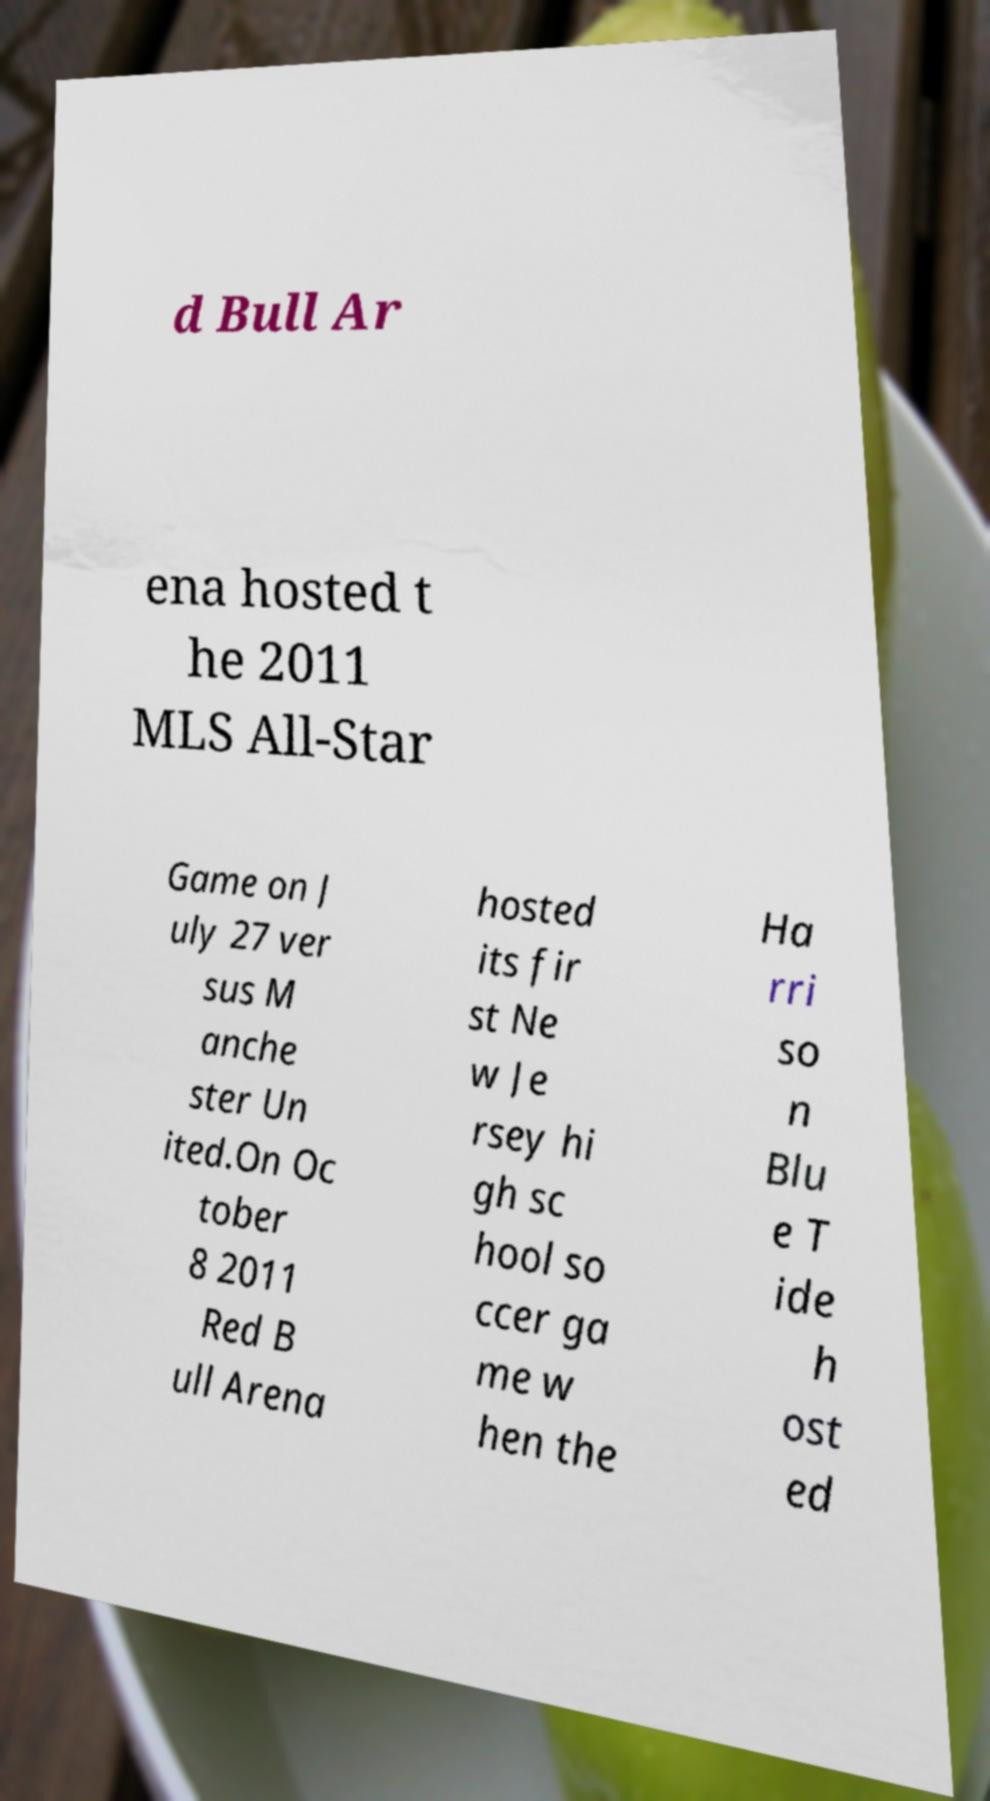Can you accurately transcribe the text from the provided image for me? d Bull Ar ena hosted t he 2011 MLS All-Star Game on J uly 27 ver sus M anche ster Un ited.On Oc tober 8 2011 Red B ull Arena hosted its fir st Ne w Je rsey hi gh sc hool so ccer ga me w hen the Ha rri so n Blu e T ide h ost ed 